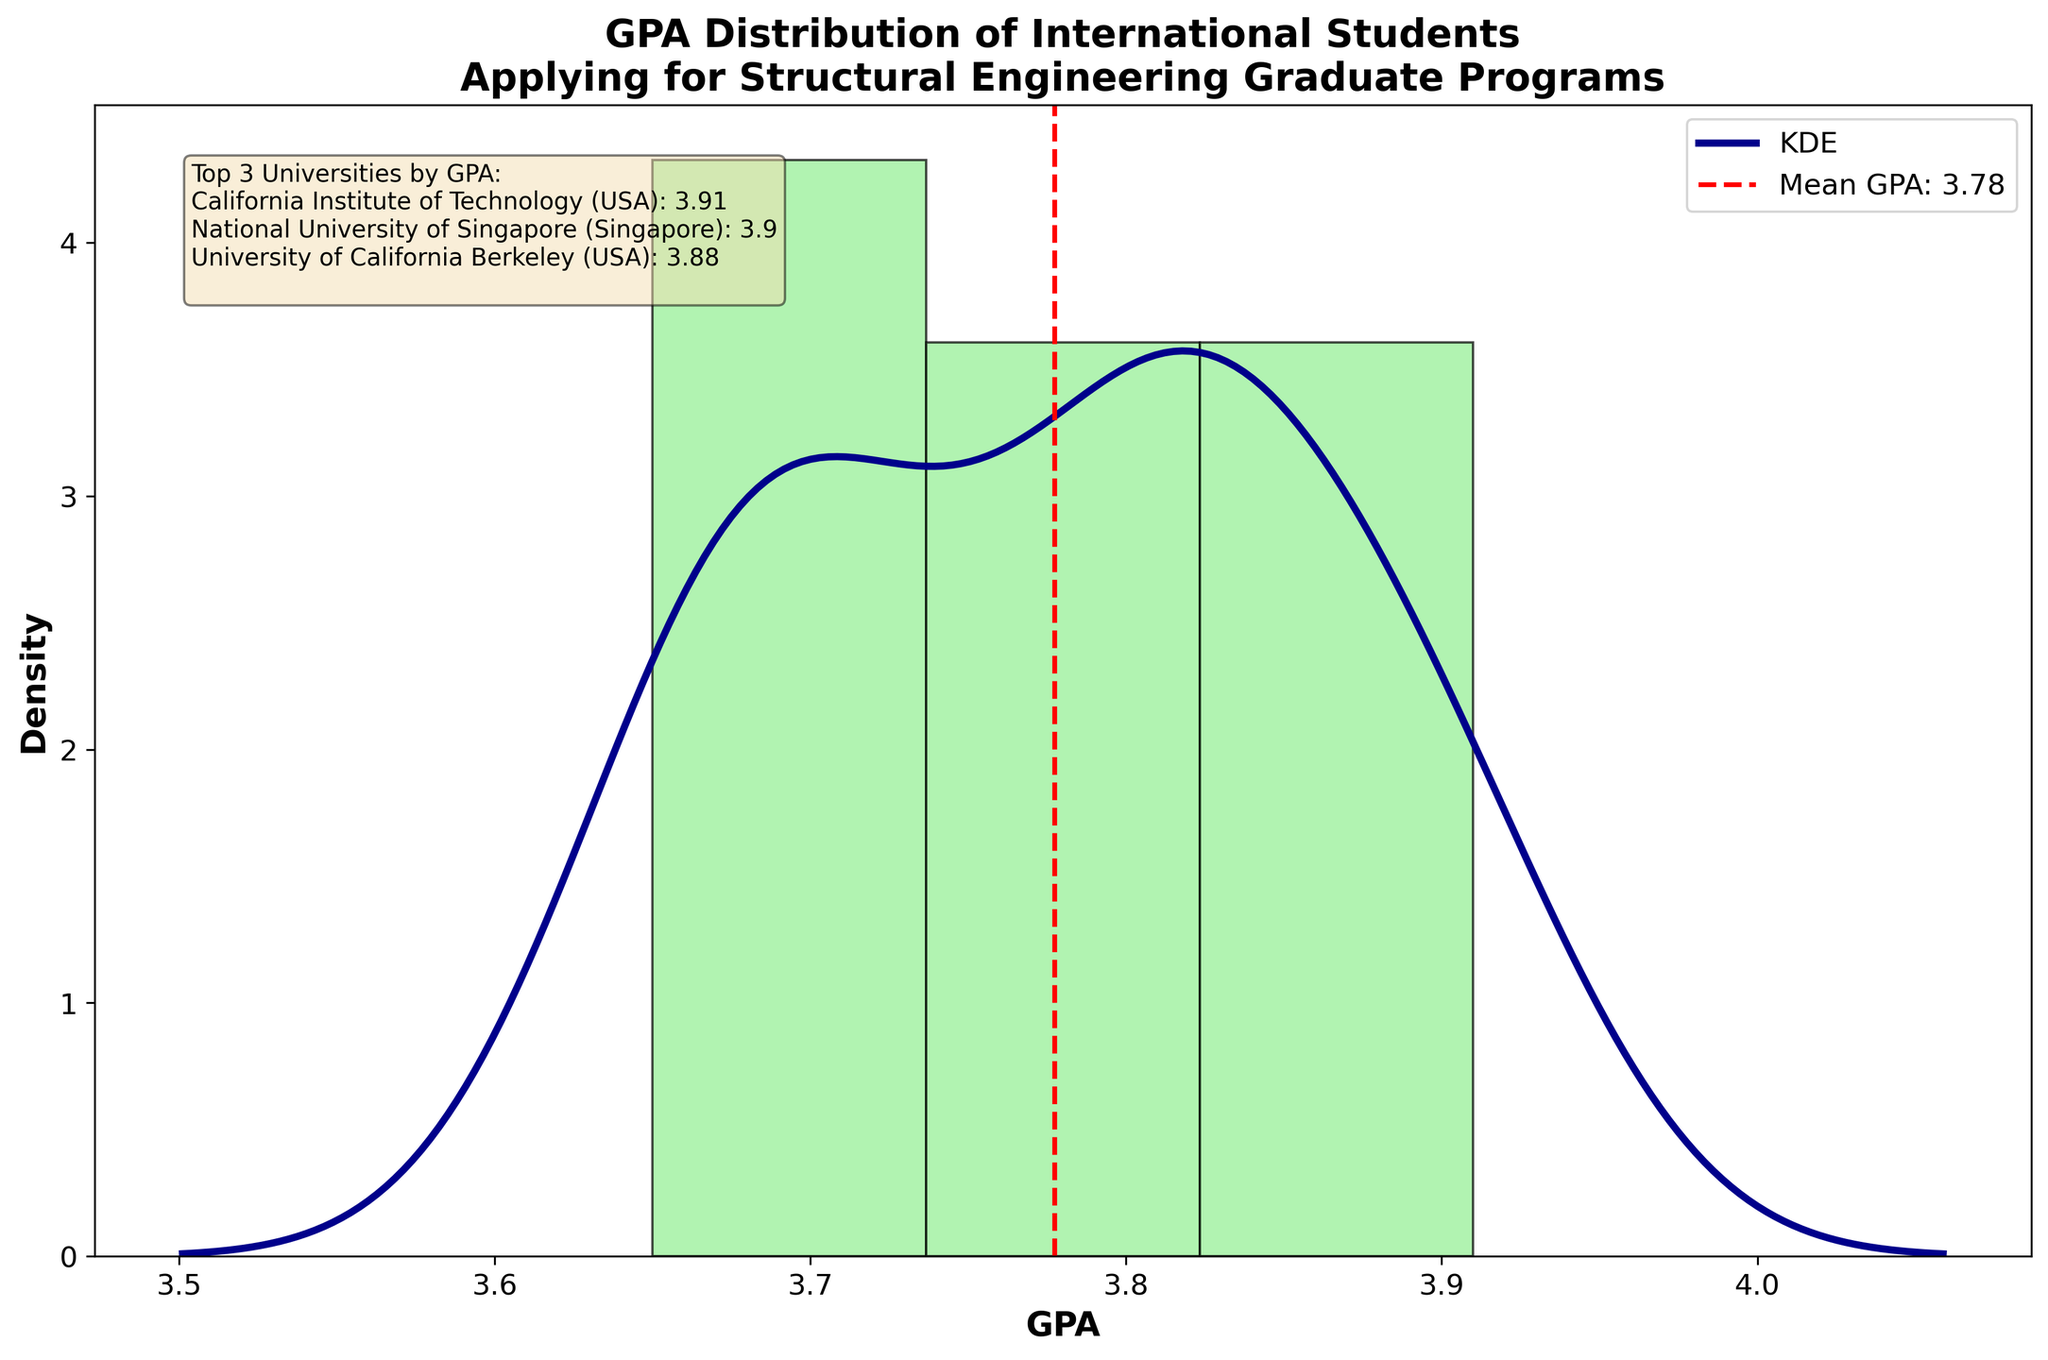what is the title of the plot? The title of the plot is displayed at the top of the chart. It reads "GPA Distribution of International Students Applying for Structural Engineering Graduate Programs."
Answer: GPA Distribution of International Students Applying for Structural Engineering Graduate Programs How many data points are included in the plot? By counting the number of bars in the histogram or identifying individual points when the curve appears, we find there are 16 data points representing various GPAs.
Answer: 16 What is the range of the GPA values shown in the plot? Looking at the x-axis, the GPA ranges from around 3.65 to 3.91. This is determined by observing the minimum and maximum values marked on the x-axis and by inspecting the edge of the histogram bars.
Answer: 3.65 to 3.91 Where is the mean GPA line located? The mean GPA line is a vertical dashed red line on the plot. By observing its position relative to the x-axis values, we determine its approximate value.
Answer: Around 3.78 Which universities have shown the highest 3 GPAs? In the text box on the figure, the top 3 universities by GPA are listed. They are California Institute of Technology (USA) with a 3.91 GPA, National University of Singapore (Singapore) with a 3.90 GPA, and University of California Berkeley (USA) with a 3.88 GPA.
Answer: California Institute of Technology (USA), National University of Singapore (Singapore), University of California Berkeley (USA) What kind of distribution pattern is suggested by the KDE curve? The KDE (Kernel Density Estimate) curve, shown as a smooth dark blue line, suggests the distribution pattern of the data. It appears unimodal, with a single peak, indicating that most GPAs are clustered around a central value.
Answer: Unimodal distribution What is the approximate value of the peak GPA in the KDE curve? The peak of the KDE curve, which indicates the highest density of GPA values, appears to be around 3.80. This is determined by finding the highest point on the dark blue density curve.
Answer: Around 3.80 Are there any obvious outliers in the GPA distribution? Observing the histogram and KDE, all GPA values appear to be closely clustered without any significant deviation or isolated bars. Thus, there are no obvious outliers in the GPA distribution.
Answer: No How does the GPA distribution skew? By examining the shape of the histogram and the KDE curve, we can see that the distribution is slightly skewed to the left (negative skew) since the longer tail appears on the lower GPA side.
Answer: Slightly left-skewed Which country has the university with the lowest GPA among the applicants? Reviewing the data points and matching the GPA values with the corresponding universities listed in the text box, the lowest GPA of 3.65 is associated with Tsinghua University in China.
Answer: China 